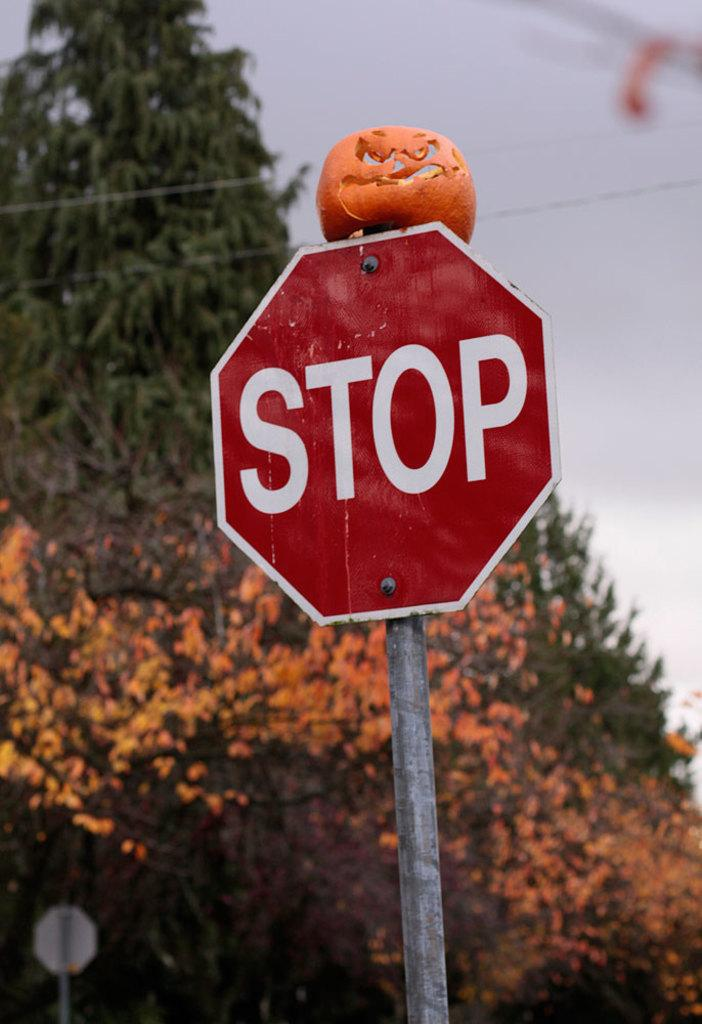<image>
Relay a brief, clear account of the picture shown. A partially squashed pumpkin sits on top of a stop sign. 